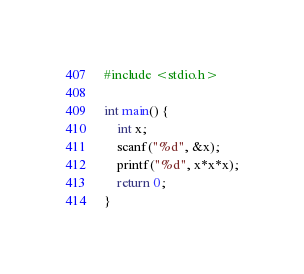Convert code to text. <code><loc_0><loc_0><loc_500><loc_500><_C_>#include <stdio.h>

int main() {
    int x;
    scanf("%d", &x);
    printf("%d", x*x*x);
    return 0;
}</code> 